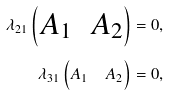Convert formula to latex. <formula><loc_0><loc_0><loc_500><loc_500>\lambda _ { 2 1 } \begin{pmatrix} A _ { 1 } & A _ { 2 } \end{pmatrix} & = 0 , \\ \lambda _ { 3 1 } \begin{pmatrix} A _ { 1 } & A _ { 2 } \end{pmatrix} & = 0 ,</formula> 